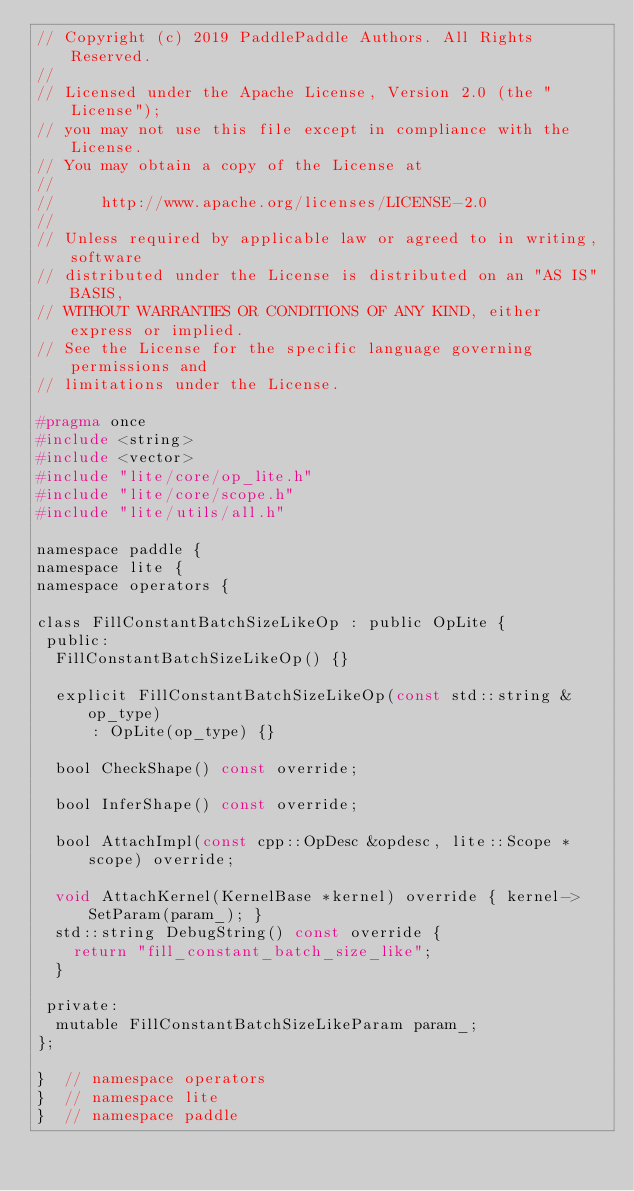Convert code to text. <code><loc_0><loc_0><loc_500><loc_500><_C_>// Copyright (c) 2019 PaddlePaddle Authors. All Rights Reserved.
//
// Licensed under the Apache License, Version 2.0 (the "License");
// you may not use this file except in compliance with the License.
// You may obtain a copy of the License at
//
//     http://www.apache.org/licenses/LICENSE-2.0
//
// Unless required by applicable law or agreed to in writing, software
// distributed under the License is distributed on an "AS IS" BASIS,
// WITHOUT WARRANTIES OR CONDITIONS OF ANY KIND, either express or implied.
// See the License for the specific language governing permissions and
// limitations under the License.

#pragma once
#include <string>
#include <vector>
#include "lite/core/op_lite.h"
#include "lite/core/scope.h"
#include "lite/utils/all.h"

namespace paddle {
namespace lite {
namespace operators {

class FillConstantBatchSizeLikeOp : public OpLite {
 public:
  FillConstantBatchSizeLikeOp() {}

  explicit FillConstantBatchSizeLikeOp(const std::string &op_type)
      : OpLite(op_type) {}

  bool CheckShape() const override;

  bool InferShape() const override;

  bool AttachImpl(const cpp::OpDesc &opdesc, lite::Scope *scope) override;

  void AttachKernel(KernelBase *kernel) override { kernel->SetParam(param_); }
  std::string DebugString() const override {
    return "fill_constant_batch_size_like";
  }

 private:
  mutable FillConstantBatchSizeLikeParam param_;
};

}  // namespace operators
}  // namespace lite
}  // namespace paddle
</code> 